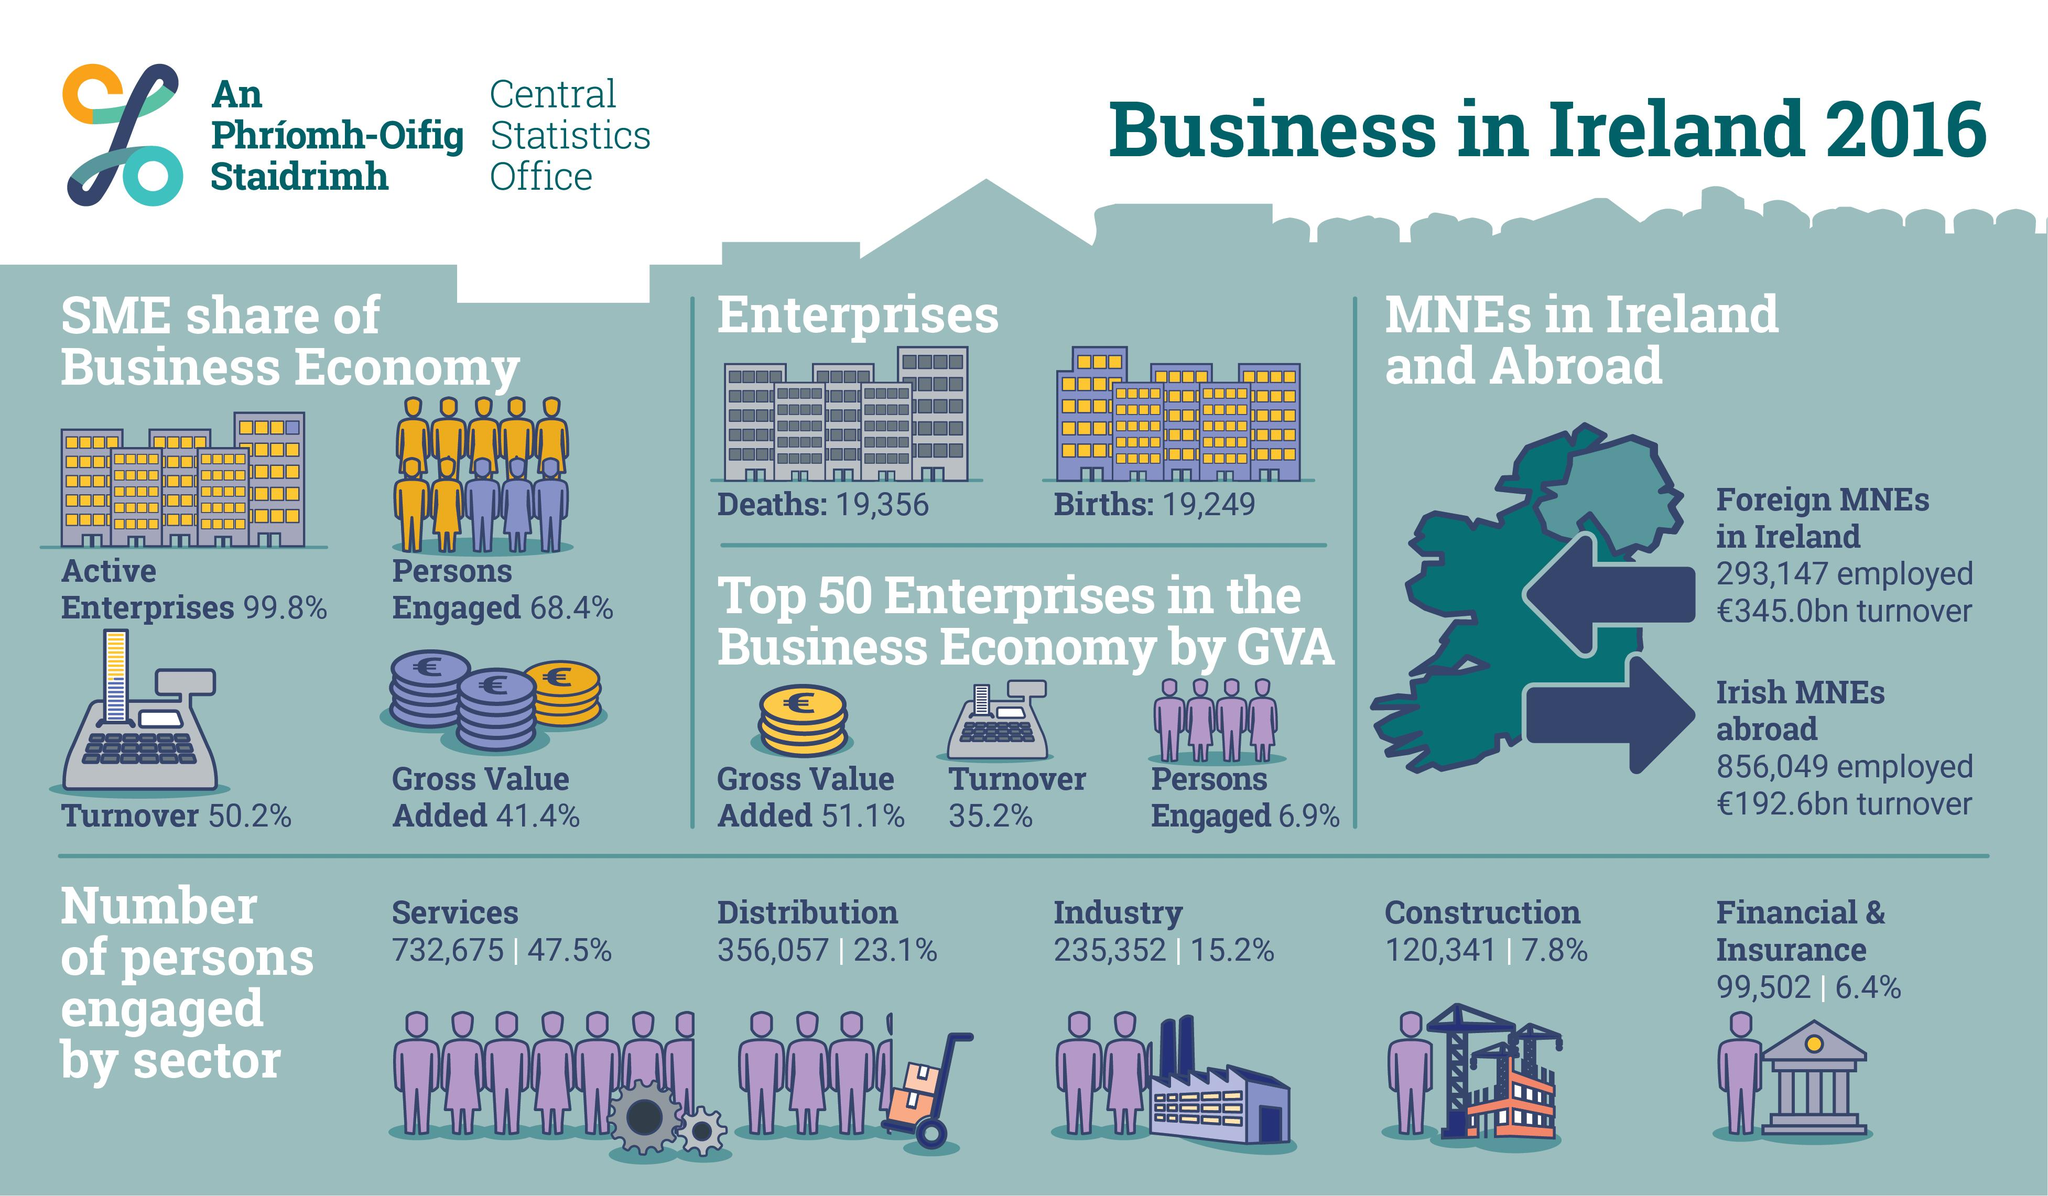Highlight a few significant elements in this photo. It is Foreign MNEs in Ireland that have a higher turnover than MNEs in Ireland. The difference between the births and deaths of enterprises is 107... In the third highest employee count among industries, the sector plays a significant role. According to the data provided, there were 591,409 people engaged in the distribution and industry sectors in a certain period. 